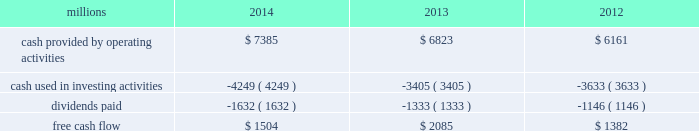Generate cash without additional external financings .
Free cash flow should be considered in addition to , rather than as a substitute for , cash provided by operating activities .
The table reconciles cash provided by operating activities ( gaap measure ) to free cash flow ( non-gaap measure ) : millions 2014 2013 2012 .
2015 outlook f0b7 safety 2013 operating a safe railroad benefits all our constituents : our employees , customers , shareholders and the communities we serve .
We will continue using a multi-faceted approach to safety , utilizing technology , risk assessment , quality control , training and employee engagement , and targeted capital investments .
We will continue using and expanding the deployment of total safety culture and courage to care throughout our operations , which allows us to identify and implement best practices for employee and operational safety .
We will continue our efforts to increase detection of rail defects ; improve or close crossings ; and educate the public and law enforcement agencies about crossing safety through a combination of our own programs ( including risk assessment strategies ) , industry programs and local community activities across our network .
F0b7 network operations 2013 in 2015 , we will continue to add resources to support growth , improve service , and replenish our surge capability .
F0b7 fuel prices 2013 with the dramatic drop in fuel prices at the end of 2014 , there is even more uncertainty around the projections of fuel prices .
We again could see volatile fuel prices during the year , as they are sensitive to global and u.s .
Domestic demand , refining capacity , geopolitical events , weather conditions and other factors .
As prices fluctuate there will be a timing impact on earnings , as our fuel surcharge programs trail fluctuations in fuel price by approximately two months .
Lower fuel prices could have a positive impact on the economy by increasing consumer discretionary spending that potentially could increase demand for various consumer products that we transport .
Alternatively , lower fuel prices will likely have a negative impact on other commodities such as coal , frac sand and crude oil shipments .
F0b7 capital plan 2013 in 2015 , we expect our capital plan to be approximately $ 4.3 billion , including expenditures for ptc and 218 locomotives .
The capital plan may be revised if business conditions warrant or if new laws or regulations affect our ability to generate sufficient returns on these investments .
( see further discussion in this item 7 under liquidity and capital resources 2013 capital plan. ) f0b7 financial expectations 2013 we expect the overall u.s .
Economy to continue to improve at a moderate pace .
One of the biggest uncertainties is the outlook for energy markets , which will bring both challenges and opportunities .
On balance , we expect to see positive volume growth for 2015 versus the prior year .
In the current environment , we expect continued margin improvement driven by continued pricing opportunities , ongoing productivity initiatives and the ability to leverage our resources as we improve the fluidity of our network. .
What was the percentage change in free cash flow from 2013 to 2014? 
Computations: ((1504 - 2085) / 2085)
Answer: -0.27866. 